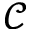<formula> <loc_0><loc_0><loc_500><loc_500>\mathcal { C }</formula> 